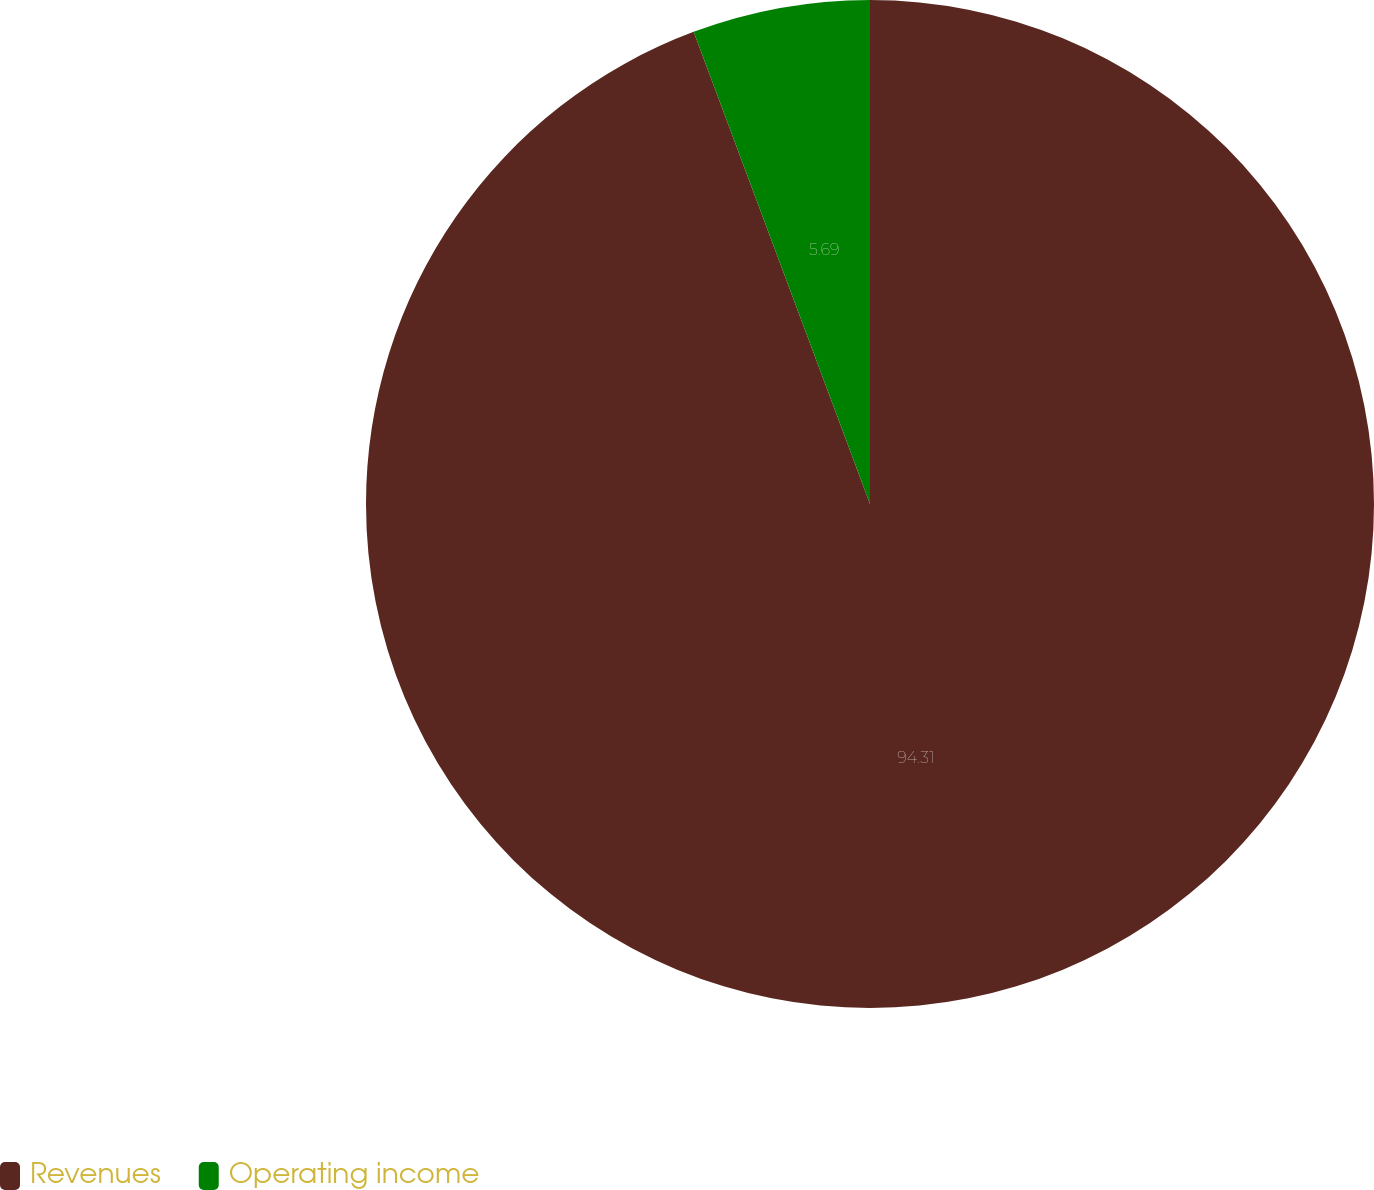Convert chart. <chart><loc_0><loc_0><loc_500><loc_500><pie_chart><fcel>Revenues<fcel>Operating income<nl><fcel>94.31%<fcel>5.69%<nl></chart> 